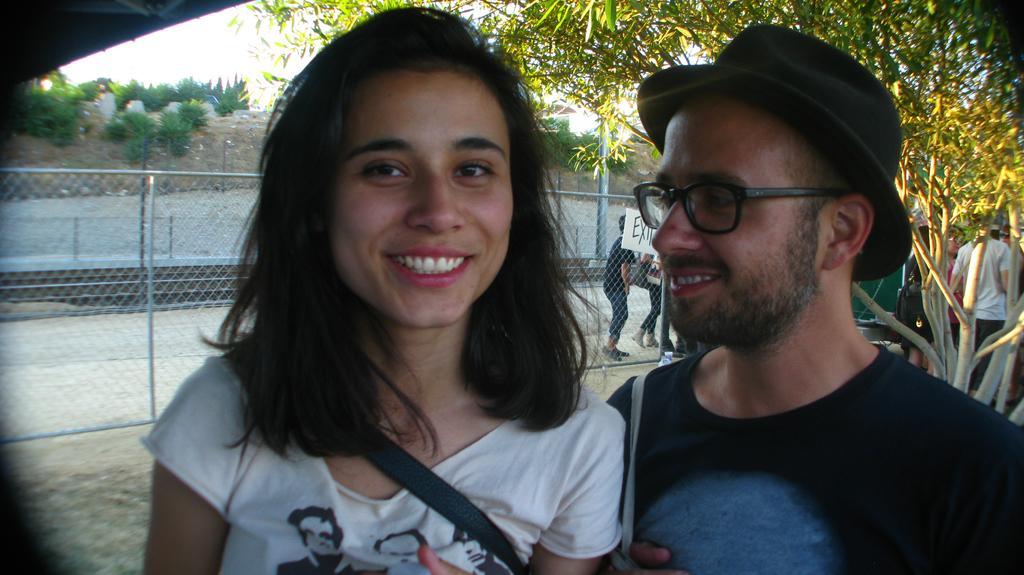Can you describe this image briefly? In the center of the image a lady and a man are there. In the background of the image we can see fencing, board, trees and some persons are there. At the top of the image sky, bushes, ground are there. At the top left corner roof is there. At the bottom of the image ground is there. 